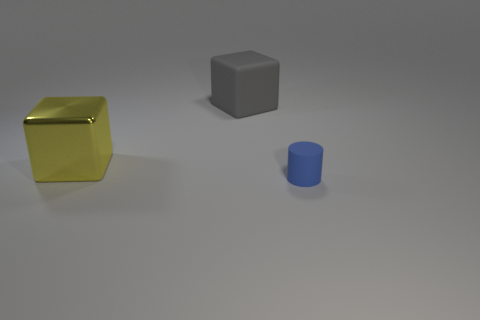Are there any shadows that might help us understand the light source? Yes, there are shadows present. Each object casts a faint but discernible shadow directly opposite to its shape, suggesting a light source coming from the front left of the scene. The shadows are soft and do not have sharp edges, which could indicate the light source is not extremely close or of a diffused nature. 